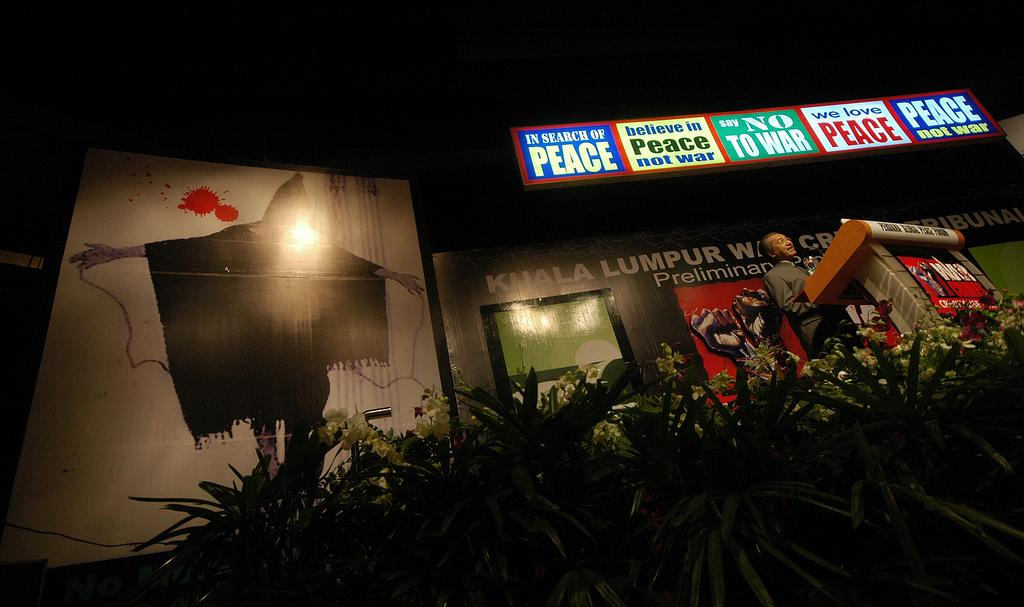What type of plants are present in the image? There are plants with flowers in the image. What is the man doing in the image? The man is standing at a podium. Can you describe any objects in the image? Yes, there are objects in the image. What can be seen in the background of the image? There are posters visible in the background. How would you describe the lighting in the image? The background is dark. What grade does the man receive for his speech in the image? There is no indication of a grade or evaluation in the image; the man is simply standing at a podium. What type of sponge is used to clean the plants in the image? There is no sponge present in the image, and the plants are not being cleaned. 